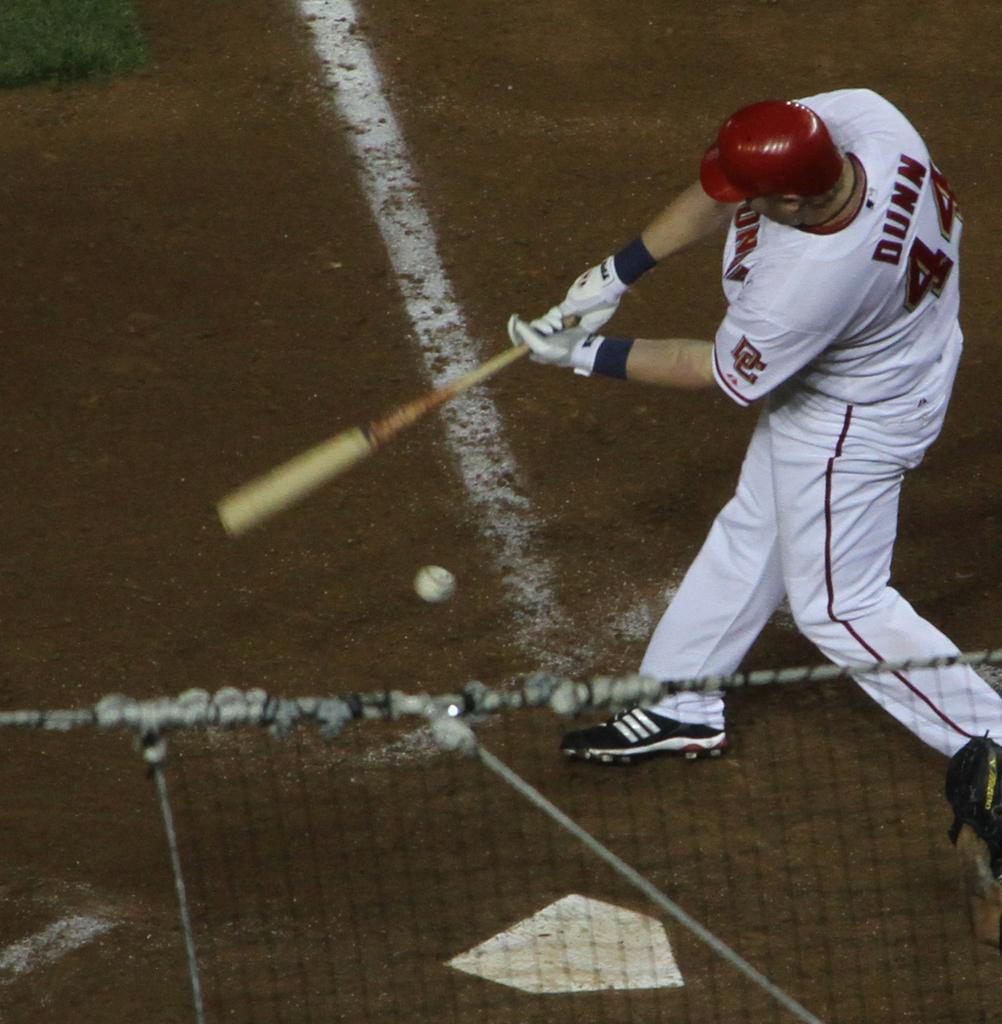<image>
Offer a succinct explanation of the picture presented. A man wearing number 44 swings his bat at the ball 